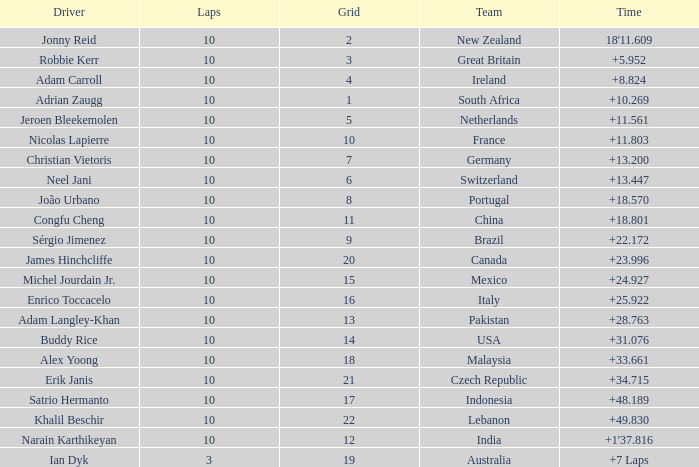What team had 10 Labs and the Driver was Alex Yoong? Malaysia. 